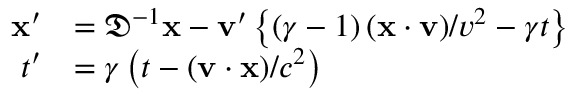<formula> <loc_0><loc_0><loc_500><loc_500>{ \begin{array} { c } { { \begin{array} { r l } { x ^ { \prime } } & { = { \mathfrak { D } } ^ { - 1 } x - v ^ { \prime } \left \{ \left ( \gamma - 1 \right ) ( x \cdot v ) / v ^ { 2 } - \gamma t \right \} } \\ { t ^ { \prime } } & { = \gamma \left ( t - ( v \cdot x ) / c ^ { 2 } \right ) } \end{array} } } \end{array} }</formula> 